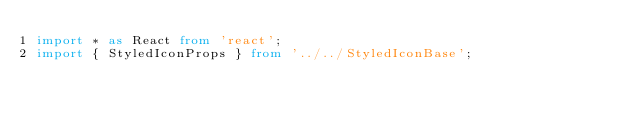<code> <loc_0><loc_0><loc_500><loc_500><_TypeScript_>import * as React from 'react';
import { StyledIconProps } from '../../StyledIconBase';</code> 